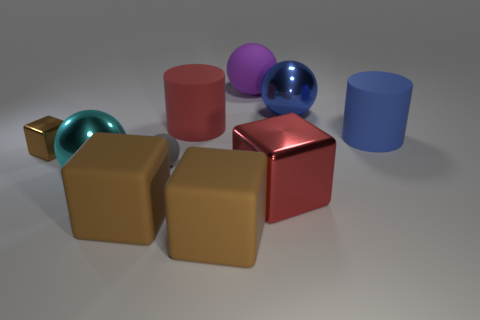How many rubber objects are large gray cylinders or tiny brown cubes?
Ensure brevity in your answer.  0. Is the material of the large cyan thing the same as the large red cylinder?
Give a very brief answer. No. What is the material of the block behind the metallic ball that is in front of the brown metal cube?
Ensure brevity in your answer.  Metal. How many large objects are either cyan objects or balls?
Provide a short and direct response. 3. The red shiny cube has what size?
Make the answer very short. Large. Is the number of large red rubber cylinders to the left of the large blue shiny sphere greater than the number of tiny matte cubes?
Your response must be concise. Yes. Is the number of red cubes that are behind the tiny brown block the same as the number of large rubber cylinders that are on the left side of the big blue sphere?
Give a very brief answer. No. What is the color of the big sphere that is in front of the big purple thing and behind the tiny brown metal cube?
Offer a very short reply. Blue. Is the number of red objects that are in front of the gray rubber ball greater than the number of large red cubes behind the tiny brown shiny object?
Offer a terse response. Yes. Do the rubber ball in front of the blue sphere and the brown metal object have the same size?
Provide a short and direct response. Yes. 